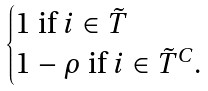<formula> <loc_0><loc_0><loc_500><loc_500>\begin{cases} 1 \text { if } i \in \tilde { T } \\ 1 - \rho \text { if } i \in \tilde { T } ^ { C } . \end{cases}</formula> 